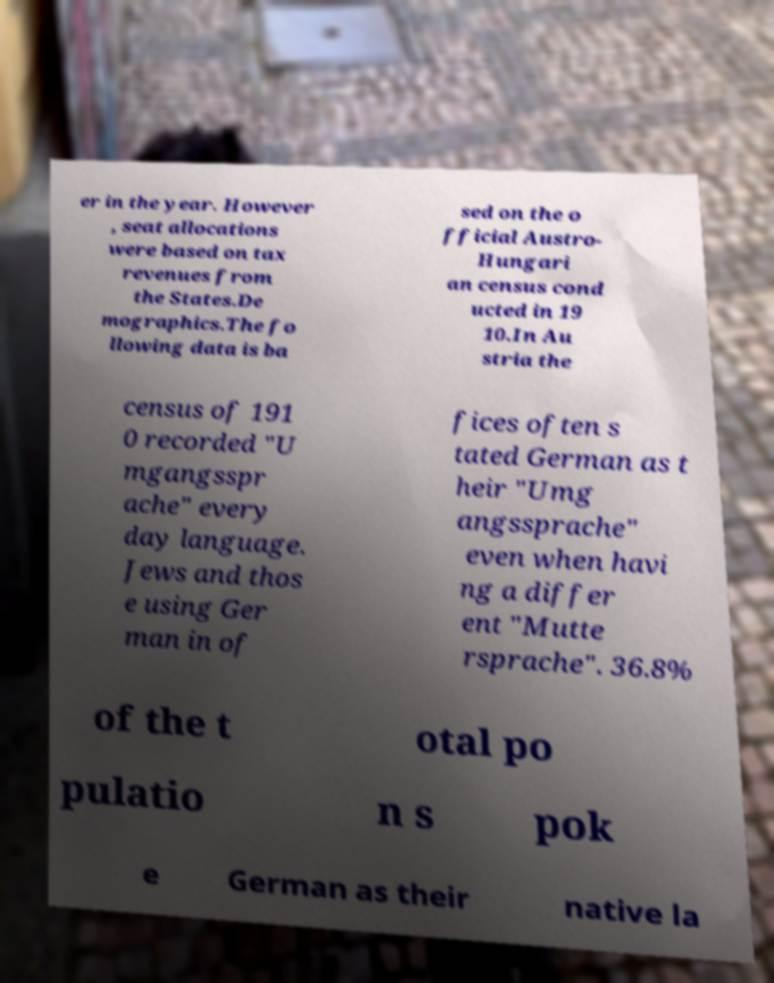I need the written content from this picture converted into text. Can you do that? er in the year. However , seat allocations were based on tax revenues from the States.De mographics.The fo llowing data is ba sed on the o fficial Austro- Hungari an census cond ucted in 19 10.In Au stria the census of 191 0 recorded "U mgangsspr ache" every day language. Jews and thos e using Ger man in of fices often s tated German as t heir "Umg angssprache" even when havi ng a differ ent "Mutte rsprache". 36.8% of the t otal po pulatio n s pok e German as their native la 